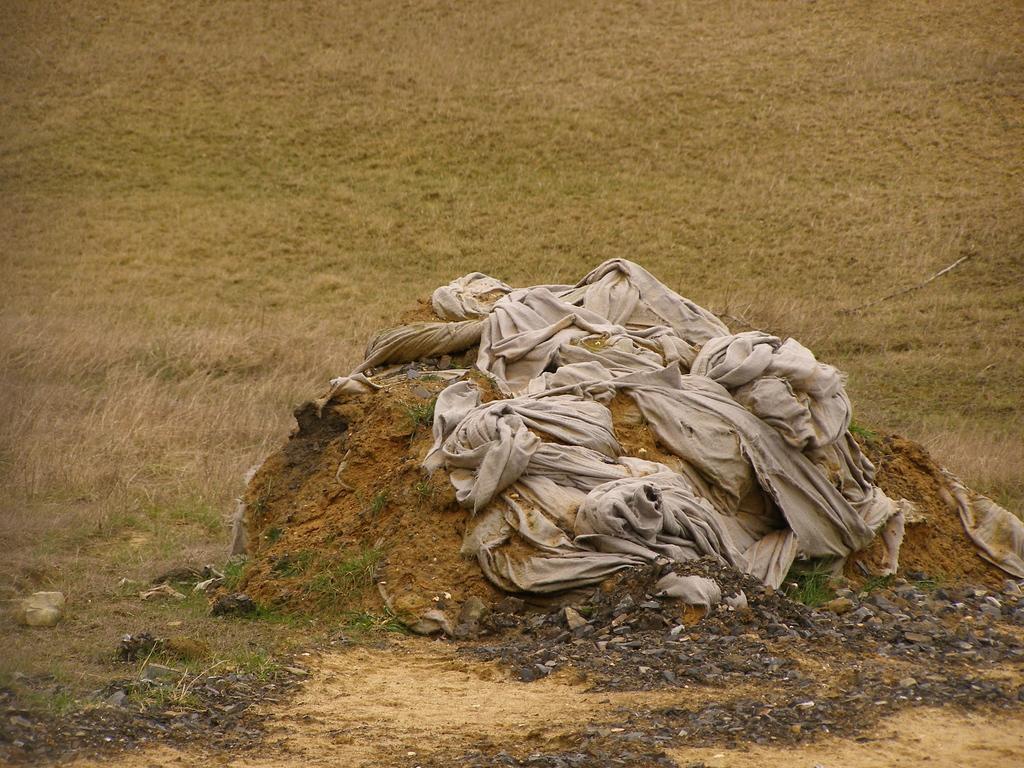What type of terrain is visible in the image? There is grassland in the image. What object can be seen on the mud in the image? There is a wet cloth on the mud in the image. What time of day is it in the image? The time of day cannot be determined from the image, as there are no indicators of time present. 